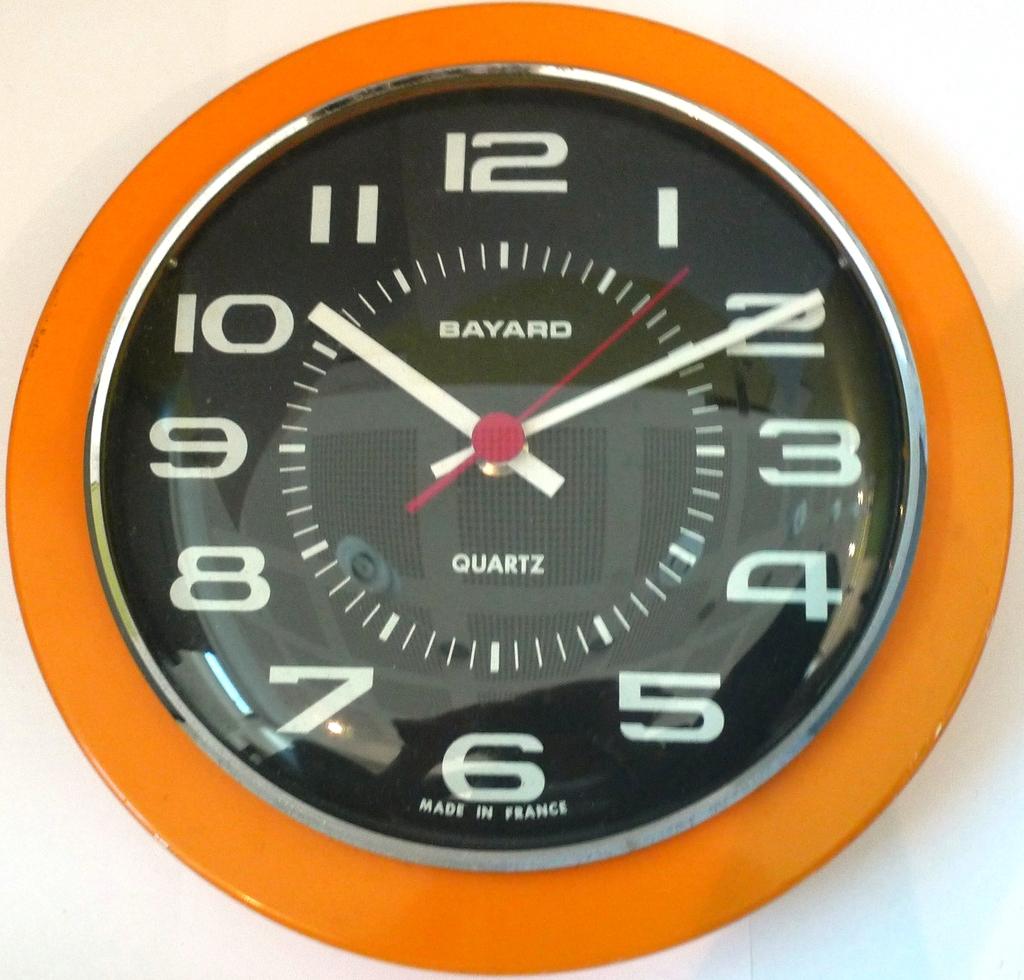Does the clock say its 2 :51?
Give a very brief answer. No. What is the brand name of the clock?
Make the answer very short. Bayard. 